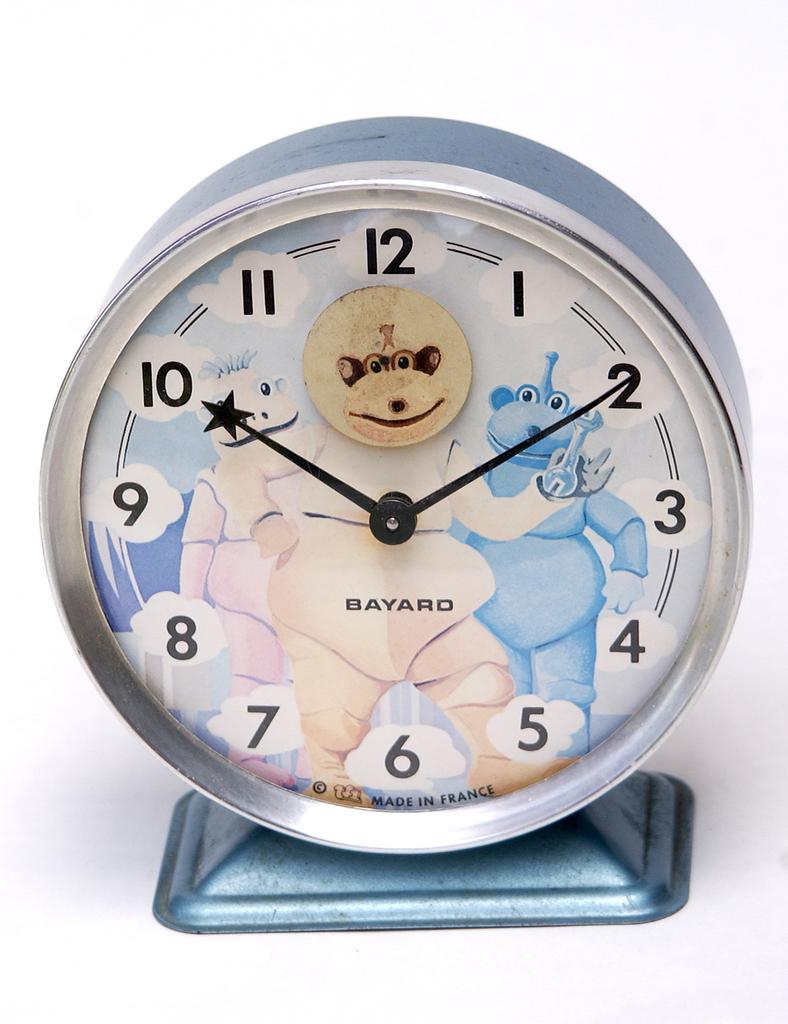<image>
Give a short and clear explanation of the subsequent image. A Bayard clock shows a silly background behind the glass. 